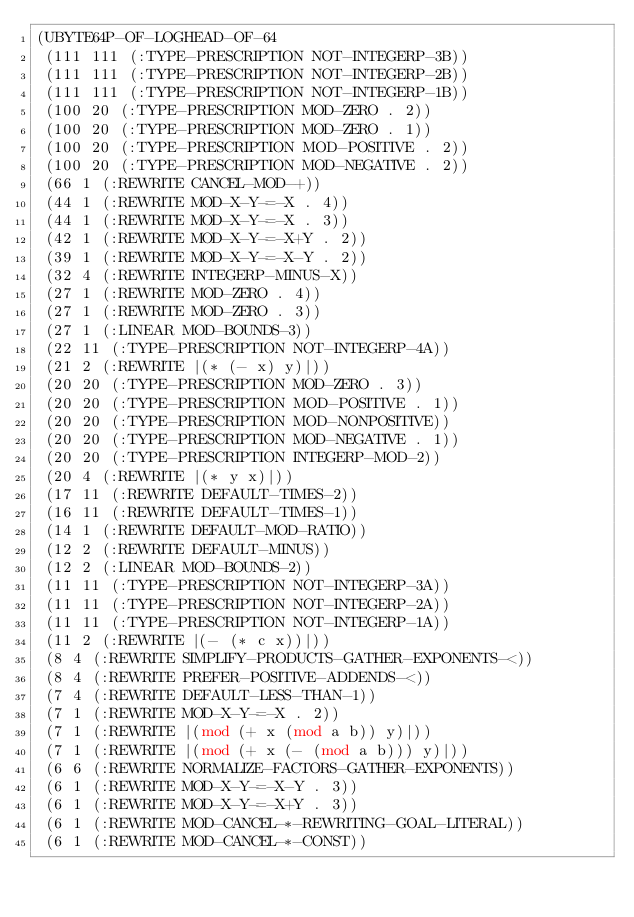Convert code to text. <code><loc_0><loc_0><loc_500><loc_500><_Lisp_>(UBYTE64P-OF-LOGHEAD-OF-64
 (111 111 (:TYPE-PRESCRIPTION NOT-INTEGERP-3B))
 (111 111 (:TYPE-PRESCRIPTION NOT-INTEGERP-2B))
 (111 111 (:TYPE-PRESCRIPTION NOT-INTEGERP-1B))
 (100 20 (:TYPE-PRESCRIPTION MOD-ZERO . 2))
 (100 20 (:TYPE-PRESCRIPTION MOD-ZERO . 1))
 (100 20 (:TYPE-PRESCRIPTION MOD-POSITIVE . 2))
 (100 20 (:TYPE-PRESCRIPTION MOD-NEGATIVE . 2))
 (66 1 (:REWRITE CANCEL-MOD-+))
 (44 1 (:REWRITE MOD-X-Y-=-X . 4))
 (44 1 (:REWRITE MOD-X-Y-=-X . 3))
 (42 1 (:REWRITE MOD-X-Y-=-X+Y . 2))
 (39 1 (:REWRITE MOD-X-Y-=-X-Y . 2))
 (32 4 (:REWRITE INTEGERP-MINUS-X))
 (27 1 (:REWRITE MOD-ZERO . 4))
 (27 1 (:REWRITE MOD-ZERO . 3))
 (27 1 (:LINEAR MOD-BOUNDS-3))
 (22 11 (:TYPE-PRESCRIPTION NOT-INTEGERP-4A))
 (21 2 (:REWRITE |(* (- x) y)|))
 (20 20 (:TYPE-PRESCRIPTION MOD-ZERO . 3))
 (20 20 (:TYPE-PRESCRIPTION MOD-POSITIVE . 1))
 (20 20 (:TYPE-PRESCRIPTION MOD-NONPOSITIVE))
 (20 20 (:TYPE-PRESCRIPTION MOD-NEGATIVE . 1))
 (20 20 (:TYPE-PRESCRIPTION INTEGERP-MOD-2))
 (20 4 (:REWRITE |(* y x)|))
 (17 11 (:REWRITE DEFAULT-TIMES-2))
 (16 11 (:REWRITE DEFAULT-TIMES-1))
 (14 1 (:REWRITE DEFAULT-MOD-RATIO))
 (12 2 (:REWRITE DEFAULT-MINUS))
 (12 2 (:LINEAR MOD-BOUNDS-2))
 (11 11 (:TYPE-PRESCRIPTION NOT-INTEGERP-3A))
 (11 11 (:TYPE-PRESCRIPTION NOT-INTEGERP-2A))
 (11 11 (:TYPE-PRESCRIPTION NOT-INTEGERP-1A))
 (11 2 (:REWRITE |(- (* c x))|))
 (8 4 (:REWRITE SIMPLIFY-PRODUCTS-GATHER-EXPONENTS-<))
 (8 4 (:REWRITE PREFER-POSITIVE-ADDENDS-<))
 (7 4 (:REWRITE DEFAULT-LESS-THAN-1))
 (7 1 (:REWRITE MOD-X-Y-=-X . 2))
 (7 1 (:REWRITE |(mod (+ x (mod a b)) y)|))
 (7 1 (:REWRITE |(mod (+ x (- (mod a b))) y)|))
 (6 6 (:REWRITE NORMALIZE-FACTORS-GATHER-EXPONENTS))
 (6 1 (:REWRITE MOD-X-Y-=-X-Y . 3))
 (6 1 (:REWRITE MOD-X-Y-=-X+Y . 3))
 (6 1 (:REWRITE MOD-CANCEL-*-REWRITING-GOAL-LITERAL))
 (6 1 (:REWRITE MOD-CANCEL-*-CONST))</code> 